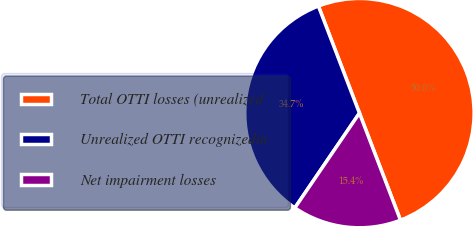Convert chart to OTSL. <chart><loc_0><loc_0><loc_500><loc_500><pie_chart><fcel>Total OTTI losses (unrealized<fcel>Unrealized OTTI recognizedin<fcel>Net impairment losses<nl><fcel>50.0%<fcel>34.65%<fcel>15.35%<nl></chart> 